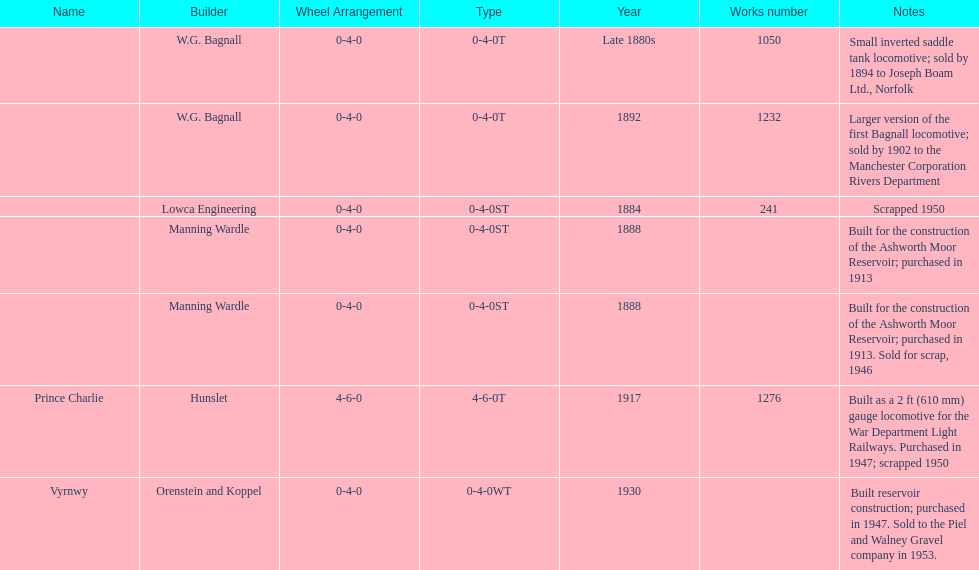What was the last locomotive? Vyrnwy. 